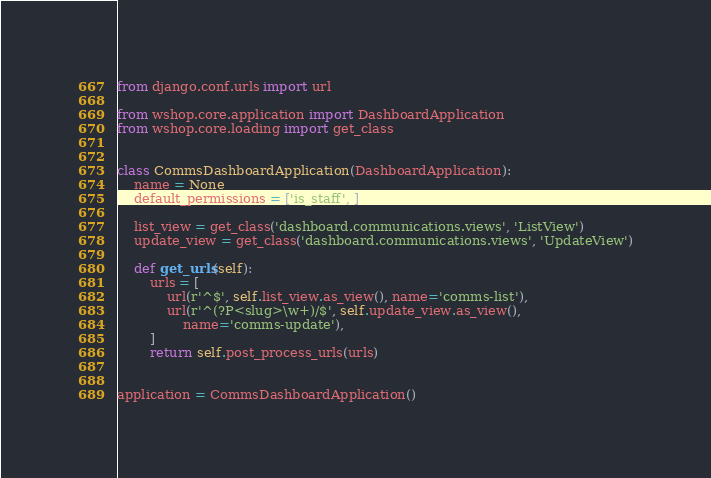Convert code to text. <code><loc_0><loc_0><loc_500><loc_500><_Python_>from django.conf.urls import url

from wshop.core.application import DashboardApplication
from wshop.core.loading import get_class


class CommsDashboardApplication(DashboardApplication):
    name = None
    default_permissions = ['is_staff', ]

    list_view = get_class('dashboard.communications.views', 'ListView')
    update_view = get_class('dashboard.communications.views', 'UpdateView')

    def get_urls(self):
        urls = [
            url(r'^$', self.list_view.as_view(), name='comms-list'),
            url(r'^(?P<slug>\w+)/$', self.update_view.as_view(),
                name='comms-update'),
        ]
        return self.post_process_urls(urls)


application = CommsDashboardApplication()
</code> 